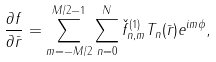Convert formula to latex. <formula><loc_0><loc_0><loc_500><loc_500>\frac { \partial f } { \partial \bar { r } } = \sum ^ { M / 2 - 1 } _ { m = - M / 2 } \sum ^ { N } _ { n = 0 } \check { f } _ { n , m } ^ { ( 1 ) } T _ { n } ( \bar { r } ) e ^ { i m \phi } ,</formula> 